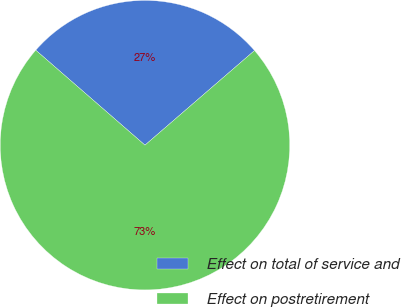<chart> <loc_0><loc_0><loc_500><loc_500><pie_chart><fcel>Effect on total of service and<fcel>Effect on postretirement<nl><fcel>27.27%<fcel>72.73%<nl></chart> 